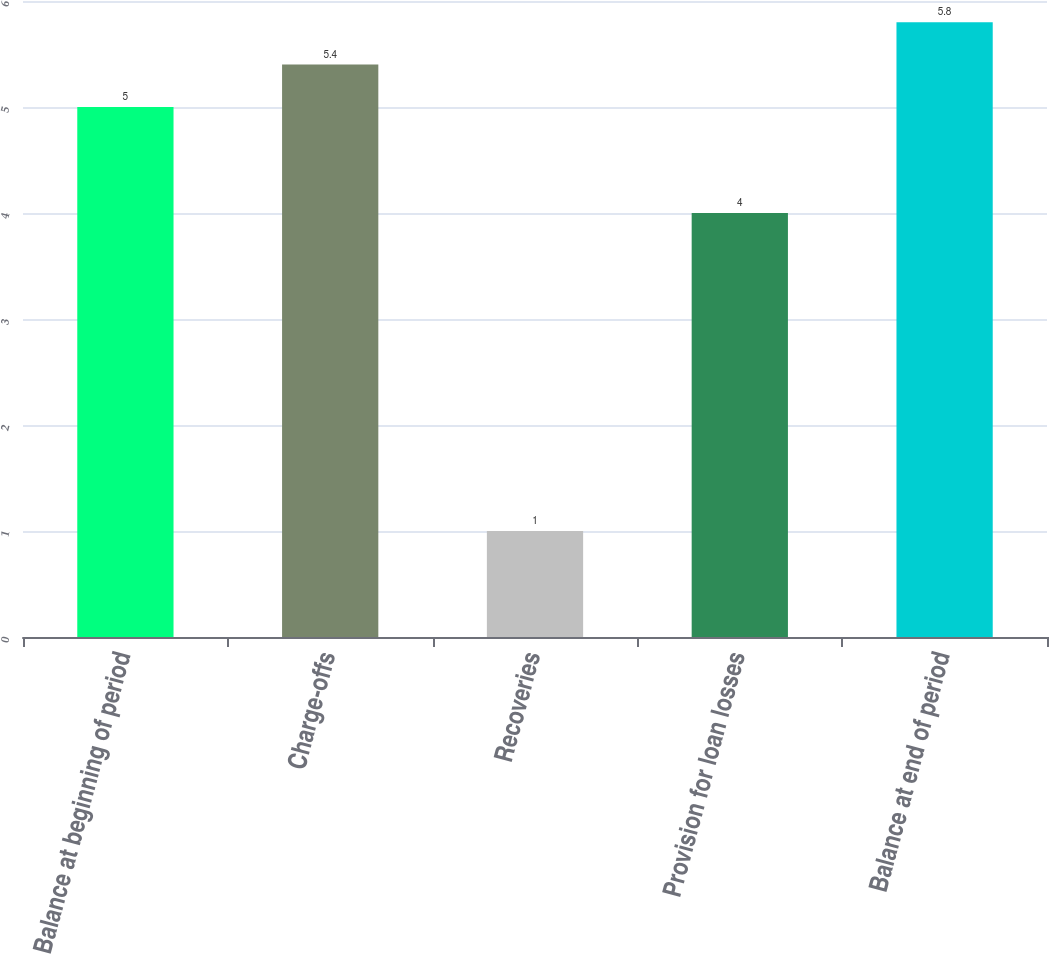Convert chart to OTSL. <chart><loc_0><loc_0><loc_500><loc_500><bar_chart><fcel>Balance at beginning of period<fcel>Charge-offs<fcel>Recoveries<fcel>Provision for loan losses<fcel>Balance at end of period<nl><fcel>5<fcel>5.4<fcel>1<fcel>4<fcel>5.8<nl></chart> 